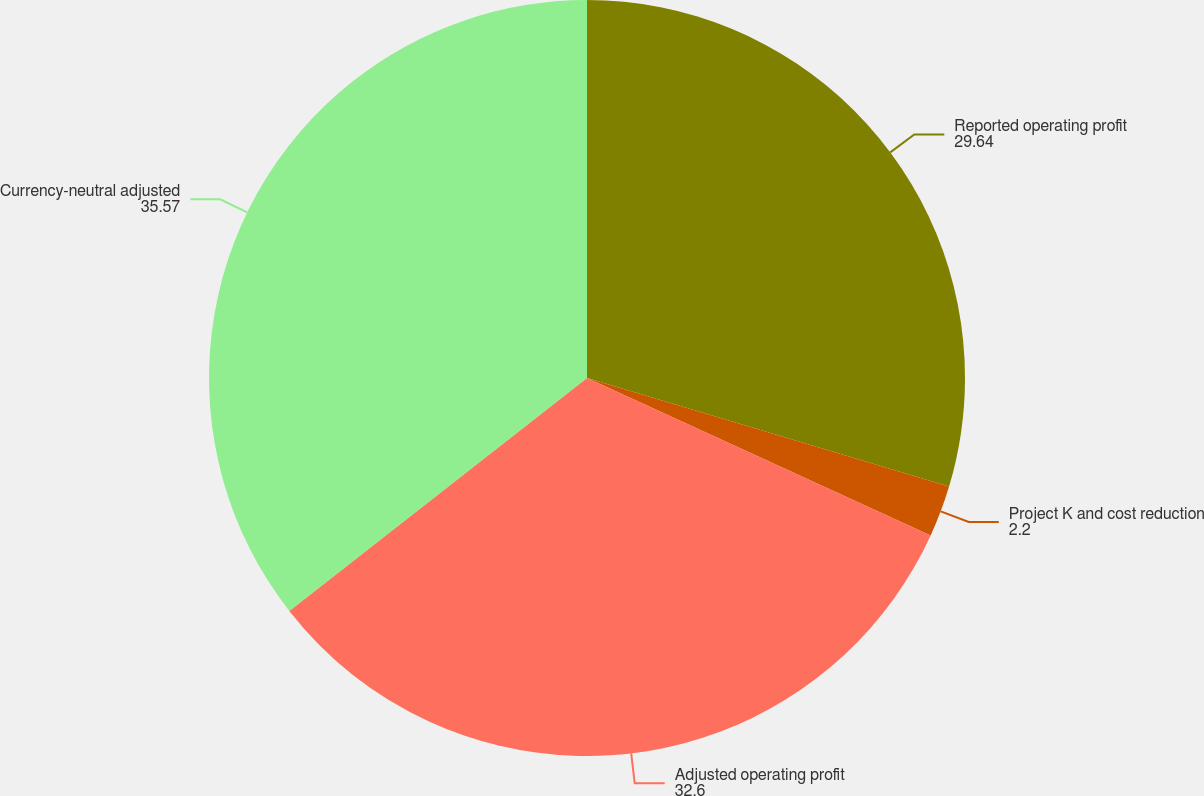<chart> <loc_0><loc_0><loc_500><loc_500><pie_chart><fcel>Reported operating profit<fcel>Project K and cost reduction<fcel>Adjusted operating profit<fcel>Currency-neutral adjusted<nl><fcel>29.64%<fcel>2.2%<fcel>32.6%<fcel>35.57%<nl></chart> 